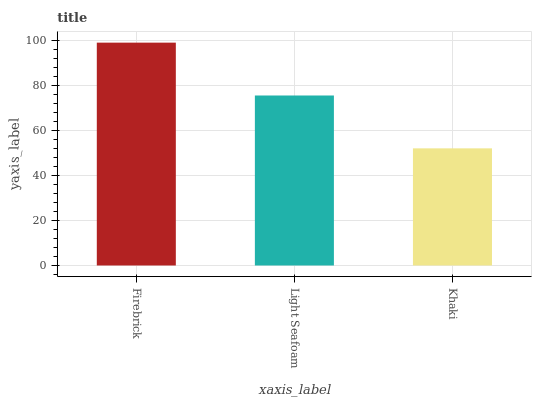Is Khaki the minimum?
Answer yes or no. Yes. Is Firebrick the maximum?
Answer yes or no. Yes. Is Light Seafoam the minimum?
Answer yes or no. No. Is Light Seafoam the maximum?
Answer yes or no. No. Is Firebrick greater than Light Seafoam?
Answer yes or no. Yes. Is Light Seafoam less than Firebrick?
Answer yes or no. Yes. Is Light Seafoam greater than Firebrick?
Answer yes or no. No. Is Firebrick less than Light Seafoam?
Answer yes or no. No. Is Light Seafoam the high median?
Answer yes or no. Yes. Is Light Seafoam the low median?
Answer yes or no. Yes. Is Firebrick the high median?
Answer yes or no. No. Is Khaki the low median?
Answer yes or no. No. 